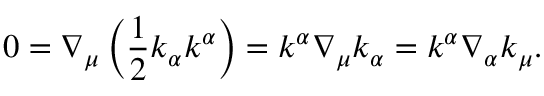<formula> <loc_0><loc_0><loc_500><loc_500>0 = \nabla _ { \mu } \left ( \frac { 1 } { 2 } k _ { \alpha } k ^ { \alpha } \right ) = k ^ { \alpha } \nabla _ { \mu } k _ { \alpha } = k ^ { \alpha } \nabla _ { \alpha } k _ { \mu } .</formula> 